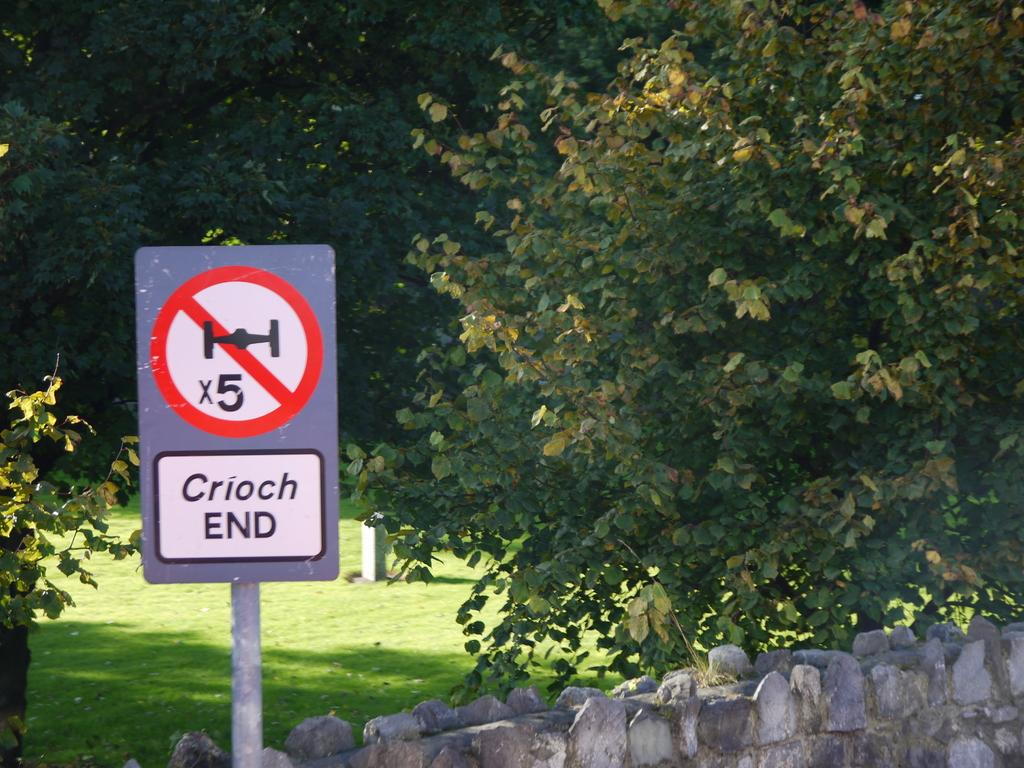<image>
Give a short and clear explanation of the subsequent image. A sign next to a stone wall says "Crioch END" and has a symbol that looks like a Star Wars ship. 